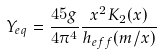Convert formula to latex. <formula><loc_0><loc_0><loc_500><loc_500>Y _ { e q } = \frac { 4 5 g } { 4 \pi ^ { 4 } } \frac { x ^ { 2 } K _ { 2 } ( x ) } { h _ { e f f } ( m / x ) }</formula> 